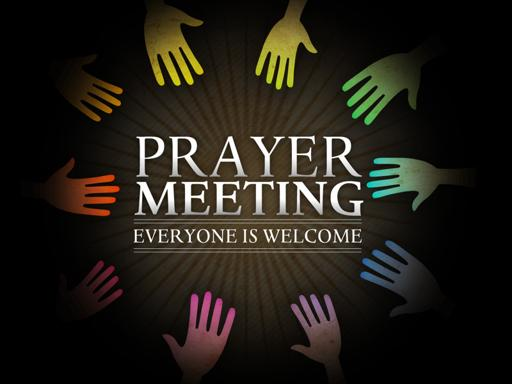How might participants feel when attending this prayer meeting? Participants at this prayer meeting might feel a strong sense of belonging and peace, as being part of a circle often fosters a feeling of inclusivity and collective focus. The warm and open invitation in the text could also make attendees feel that they are entering a safe and nurturing environment. 